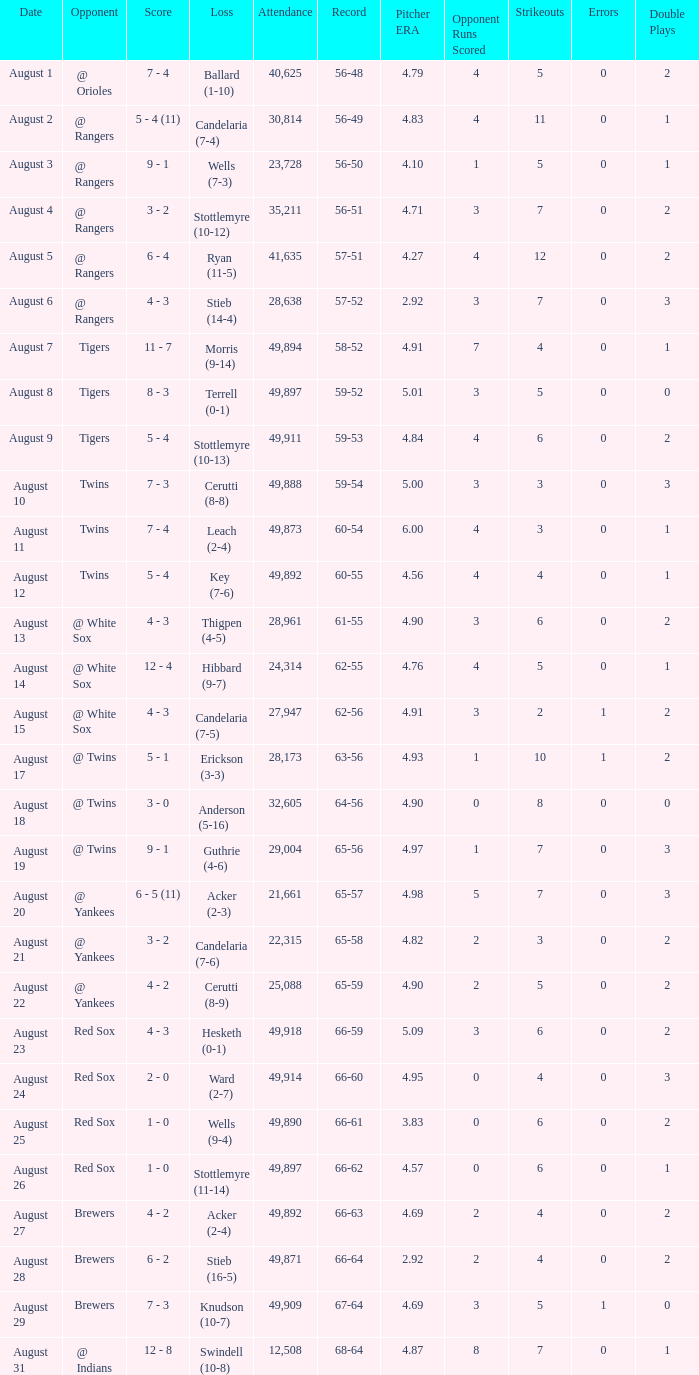What was the record of the game that had a loss of Stottlemyre (10-12)? 56-51. 